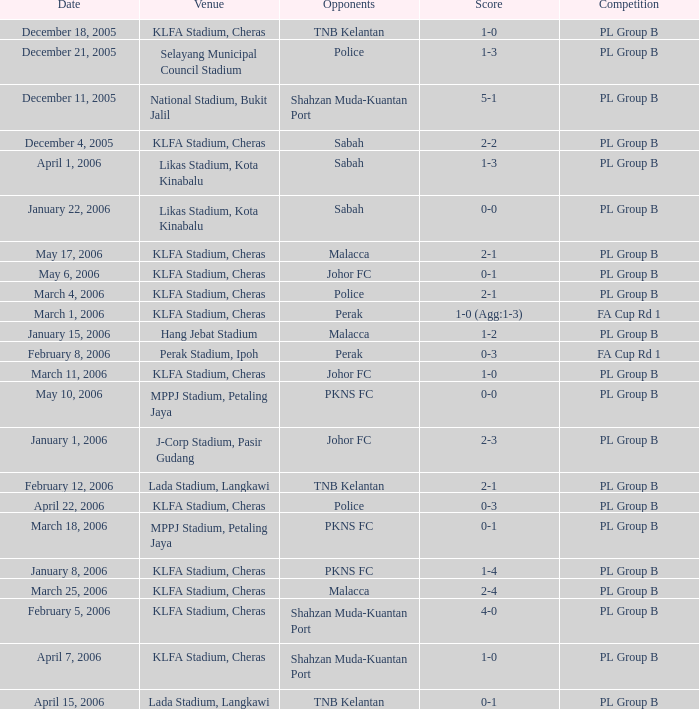On which date does a pl group b competition take place at selayang municipal council stadium, featuring opponents from the police team? December 21, 2005. 